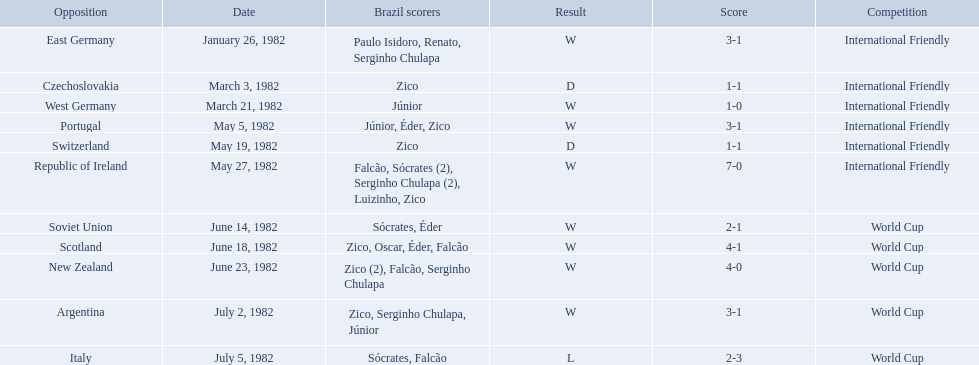I'm looking to parse the entire table for insights. Could you assist me with that? {'header': ['Opposition', 'Date', 'Brazil scorers', 'Result', 'Score', 'Competition'], 'rows': [['East Germany', 'January 26, 1982', 'Paulo Isidoro, Renato, Serginho Chulapa', 'W', '3-1', 'International Friendly'], ['Czechoslovakia', 'March 3, 1982', 'Zico', 'D', '1-1', 'International Friendly'], ['West Germany', 'March 21, 1982', 'Júnior', 'W', '1-0', 'International Friendly'], ['Portugal', 'May 5, 1982', 'Júnior, Éder, Zico', 'W', '3-1', 'International Friendly'], ['Switzerland', 'May 19, 1982', 'Zico', 'D', '1-1', 'International Friendly'], ['Republic of Ireland', 'May 27, 1982', 'Falcão, Sócrates (2), Serginho Chulapa (2), Luizinho, Zico', 'W', '7-0', 'International Friendly'], ['Soviet Union', 'June 14, 1982', 'Sócrates, Éder', 'W', '2-1', 'World Cup'], ['Scotland', 'June 18, 1982', 'Zico, Oscar, Éder, Falcão', 'W', '4-1', 'World Cup'], ['New Zealand', 'June 23, 1982', 'Zico (2), Falcão, Serginho Chulapa', 'W', '4-0', 'World Cup'], ['Argentina', 'July 2, 1982', 'Zico, Serginho Chulapa, Júnior', 'W', '3-1', 'World Cup'], ['Italy', 'July 5, 1982', 'Sócrates, Falcão', 'L', '2-3', 'World Cup']]} How many goals did brazil score against the soviet union? 2-1. How many goals did brazil score against portugal? 3-1. Did brazil score more goals against portugal or the soviet union? Portugal. 